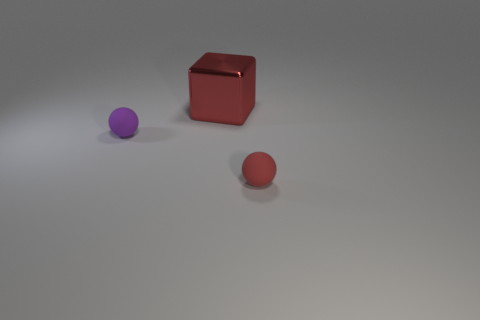Is the shape of the small rubber object on the right side of the big shiny thing the same as the thing on the left side of the big object?
Provide a short and direct response. Yes. What number of things are rubber objects or tiny rubber things on the left side of the tiny red matte sphere?
Provide a short and direct response. 2. How many other things are there of the same size as the purple rubber ball?
Give a very brief answer. 1. Are the red ball on the right side of the red shiny cube and the tiny thing that is left of the large red metallic cube made of the same material?
Give a very brief answer. Yes. How many purple rubber balls are right of the big metallic thing?
Ensure brevity in your answer.  0. What number of purple objects are tiny balls or metallic balls?
Give a very brief answer. 1. There is another ball that is the same size as the red matte ball; what is it made of?
Provide a short and direct response. Rubber. What shape is the thing that is on the left side of the red rubber ball and in front of the metallic cube?
Give a very brief answer. Sphere. The other rubber sphere that is the same size as the red rubber sphere is what color?
Your response must be concise. Purple. There is a matte object that is on the right side of the big red thing; is it the same size as the thing that is behind the tiny purple sphere?
Keep it short and to the point. No. 